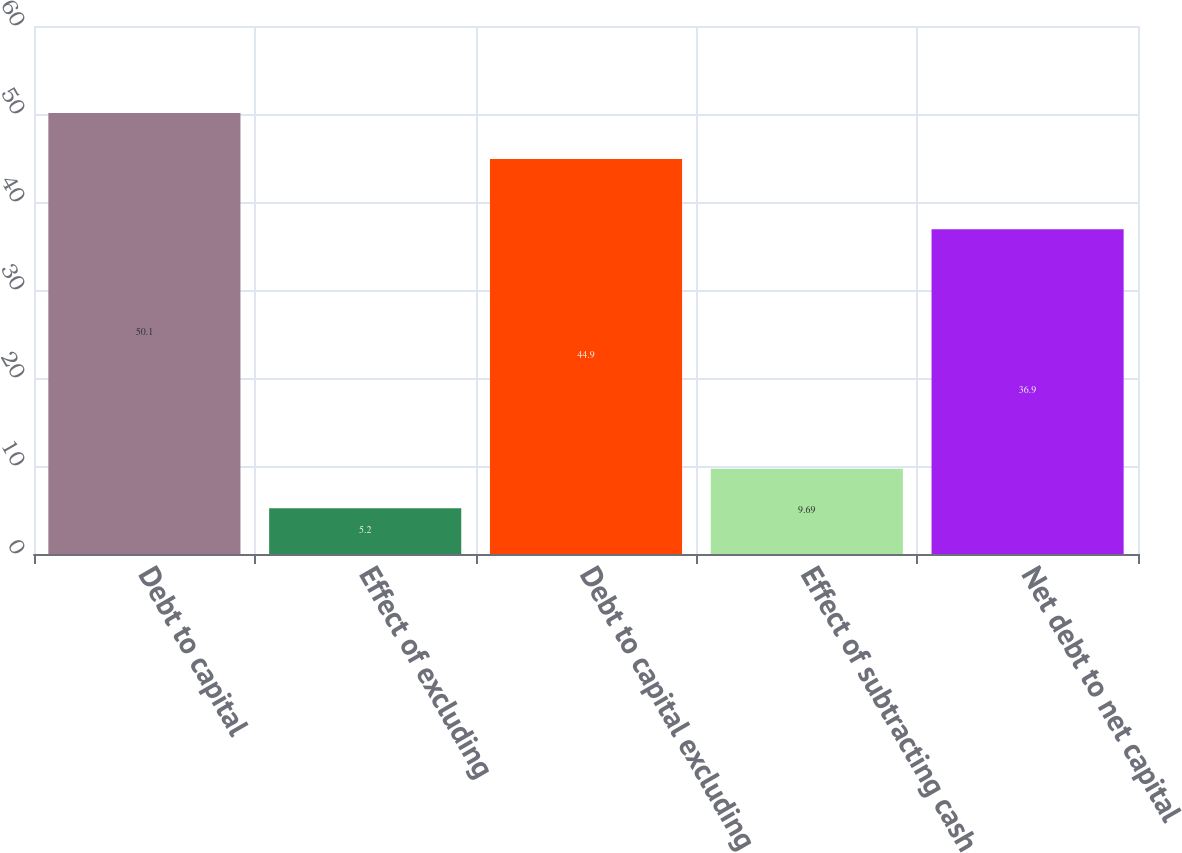<chart> <loc_0><loc_0><loc_500><loc_500><bar_chart><fcel>Debt to capital<fcel>Effect of excluding<fcel>Debt to capital excluding<fcel>Effect of subtracting cash<fcel>Net debt to net capital<nl><fcel>50.1<fcel>5.2<fcel>44.9<fcel>9.69<fcel>36.9<nl></chart> 